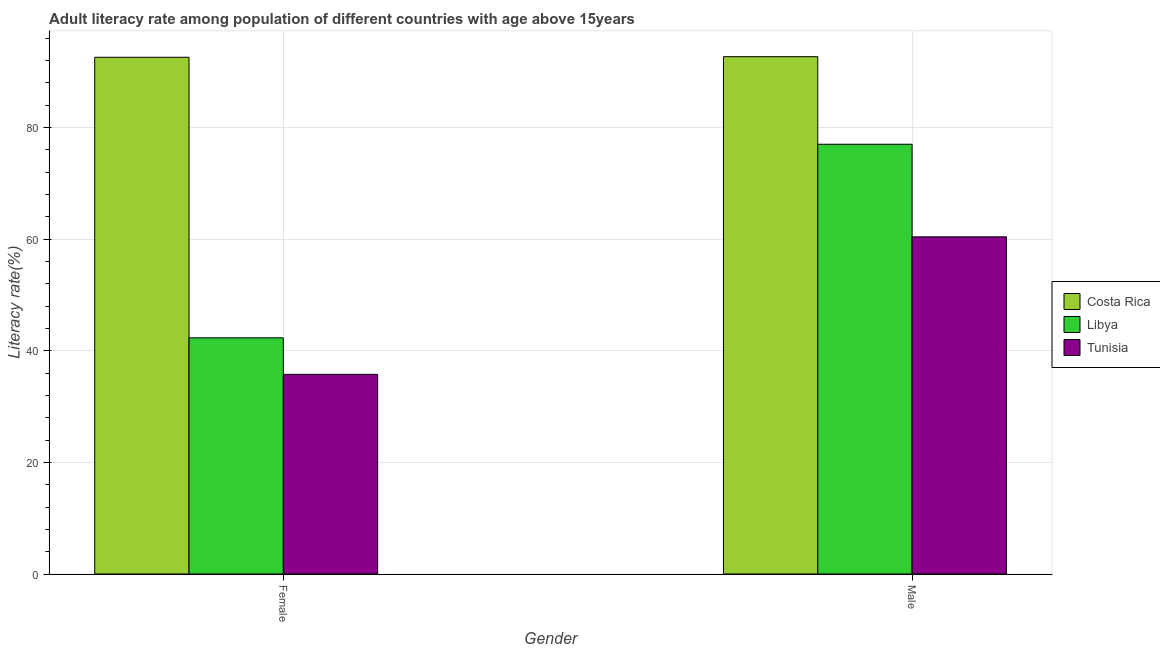How many different coloured bars are there?
Ensure brevity in your answer.  3. Are the number of bars per tick equal to the number of legend labels?
Your response must be concise. Yes. Are the number of bars on each tick of the X-axis equal?
Give a very brief answer. Yes. How many bars are there on the 2nd tick from the left?
Give a very brief answer. 3. How many bars are there on the 2nd tick from the right?
Keep it short and to the point. 3. What is the male adult literacy rate in Libya?
Your answer should be very brief. 76.99. Across all countries, what is the maximum female adult literacy rate?
Give a very brief answer. 92.58. Across all countries, what is the minimum male adult literacy rate?
Ensure brevity in your answer.  60.41. In which country was the female adult literacy rate minimum?
Provide a short and direct response. Tunisia. What is the total male adult literacy rate in the graph?
Your answer should be very brief. 230.08. What is the difference between the male adult literacy rate in Libya and that in Costa Rica?
Offer a very short reply. -15.69. What is the difference between the female adult literacy rate in Costa Rica and the male adult literacy rate in Tunisia?
Offer a terse response. 32.17. What is the average male adult literacy rate per country?
Offer a very short reply. 76.69. What is the difference between the female adult literacy rate and male adult literacy rate in Costa Rica?
Provide a succinct answer. -0.11. What is the ratio of the female adult literacy rate in Costa Rica to that in Tunisia?
Keep it short and to the point. 2.59. Is the male adult literacy rate in Tunisia less than that in Costa Rica?
Ensure brevity in your answer.  Yes. What does the 1st bar from the left in Female represents?
Offer a very short reply. Costa Rica. What does the 1st bar from the right in Female represents?
Provide a short and direct response. Tunisia. How many bars are there?
Provide a succinct answer. 6. Are all the bars in the graph horizontal?
Your answer should be very brief. No. How many countries are there in the graph?
Make the answer very short. 3. What is the difference between two consecutive major ticks on the Y-axis?
Your response must be concise. 20. Are the values on the major ticks of Y-axis written in scientific E-notation?
Provide a short and direct response. No. Does the graph contain any zero values?
Your response must be concise. No. Does the graph contain grids?
Make the answer very short. Yes. Where does the legend appear in the graph?
Your response must be concise. Center right. How many legend labels are there?
Your answer should be very brief. 3. What is the title of the graph?
Offer a very short reply. Adult literacy rate among population of different countries with age above 15years. Does "Mongolia" appear as one of the legend labels in the graph?
Give a very brief answer. No. What is the label or title of the Y-axis?
Make the answer very short. Literacy rate(%). What is the Literacy rate(%) in Costa Rica in Female?
Your answer should be compact. 92.58. What is the Literacy rate(%) in Libya in Female?
Your response must be concise. 42.31. What is the Literacy rate(%) in Tunisia in Female?
Ensure brevity in your answer.  35.77. What is the Literacy rate(%) in Costa Rica in Male?
Offer a very short reply. 92.68. What is the Literacy rate(%) of Libya in Male?
Your answer should be very brief. 76.99. What is the Literacy rate(%) of Tunisia in Male?
Keep it short and to the point. 60.41. Across all Gender, what is the maximum Literacy rate(%) in Costa Rica?
Provide a succinct answer. 92.68. Across all Gender, what is the maximum Literacy rate(%) of Libya?
Your response must be concise. 76.99. Across all Gender, what is the maximum Literacy rate(%) of Tunisia?
Your response must be concise. 60.41. Across all Gender, what is the minimum Literacy rate(%) of Costa Rica?
Ensure brevity in your answer.  92.58. Across all Gender, what is the minimum Literacy rate(%) of Libya?
Offer a very short reply. 42.31. Across all Gender, what is the minimum Literacy rate(%) of Tunisia?
Provide a succinct answer. 35.77. What is the total Literacy rate(%) in Costa Rica in the graph?
Provide a short and direct response. 185.26. What is the total Literacy rate(%) in Libya in the graph?
Provide a short and direct response. 119.31. What is the total Literacy rate(%) of Tunisia in the graph?
Keep it short and to the point. 96.17. What is the difference between the Literacy rate(%) of Costa Rica in Female and that in Male?
Your response must be concise. -0.1. What is the difference between the Literacy rate(%) of Libya in Female and that in Male?
Your response must be concise. -34.68. What is the difference between the Literacy rate(%) in Tunisia in Female and that in Male?
Keep it short and to the point. -24.64. What is the difference between the Literacy rate(%) of Costa Rica in Female and the Literacy rate(%) of Libya in Male?
Offer a terse response. 15.58. What is the difference between the Literacy rate(%) in Costa Rica in Female and the Literacy rate(%) in Tunisia in Male?
Offer a terse response. 32.17. What is the difference between the Literacy rate(%) of Libya in Female and the Literacy rate(%) of Tunisia in Male?
Provide a short and direct response. -18.09. What is the average Literacy rate(%) of Costa Rica per Gender?
Provide a succinct answer. 92.63. What is the average Literacy rate(%) in Libya per Gender?
Your answer should be compact. 59.65. What is the average Literacy rate(%) of Tunisia per Gender?
Your answer should be compact. 48.09. What is the difference between the Literacy rate(%) of Costa Rica and Literacy rate(%) of Libya in Female?
Make the answer very short. 50.26. What is the difference between the Literacy rate(%) in Costa Rica and Literacy rate(%) in Tunisia in Female?
Offer a terse response. 56.81. What is the difference between the Literacy rate(%) in Libya and Literacy rate(%) in Tunisia in Female?
Provide a succinct answer. 6.55. What is the difference between the Literacy rate(%) of Costa Rica and Literacy rate(%) of Libya in Male?
Your response must be concise. 15.69. What is the difference between the Literacy rate(%) in Costa Rica and Literacy rate(%) in Tunisia in Male?
Your answer should be compact. 32.27. What is the difference between the Literacy rate(%) of Libya and Literacy rate(%) of Tunisia in Male?
Your answer should be compact. 16.59. What is the ratio of the Literacy rate(%) in Costa Rica in Female to that in Male?
Offer a very short reply. 1. What is the ratio of the Literacy rate(%) in Libya in Female to that in Male?
Provide a succinct answer. 0.55. What is the ratio of the Literacy rate(%) of Tunisia in Female to that in Male?
Your response must be concise. 0.59. What is the difference between the highest and the second highest Literacy rate(%) in Costa Rica?
Your response must be concise. 0.1. What is the difference between the highest and the second highest Literacy rate(%) of Libya?
Offer a very short reply. 34.68. What is the difference between the highest and the second highest Literacy rate(%) in Tunisia?
Keep it short and to the point. 24.64. What is the difference between the highest and the lowest Literacy rate(%) in Costa Rica?
Provide a succinct answer. 0.1. What is the difference between the highest and the lowest Literacy rate(%) in Libya?
Give a very brief answer. 34.68. What is the difference between the highest and the lowest Literacy rate(%) of Tunisia?
Your answer should be very brief. 24.64. 